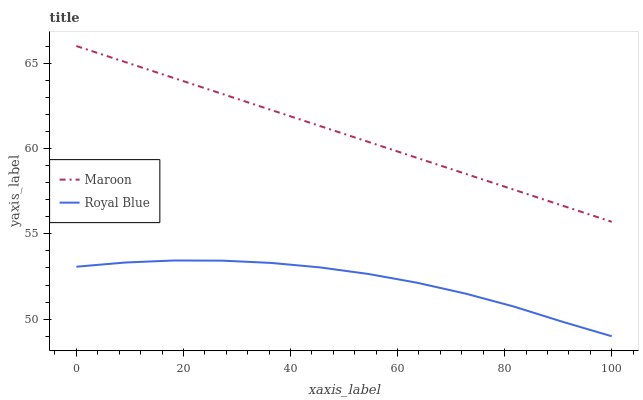Does Royal Blue have the minimum area under the curve?
Answer yes or no. Yes. Does Maroon have the maximum area under the curve?
Answer yes or no. Yes. Does Maroon have the minimum area under the curve?
Answer yes or no. No. Is Maroon the smoothest?
Answer yes or no. Yes. Is Royal Blue the roughest?
Answer yes or no. Yes. Is Maroon the roughest?
Answer yes or no. No. Does Royal Blue have the lowest value?
Answer yes or no. Yes. Does Maroon have the lowest value?
Answer yes or no. No. Does Maroon have the highest value?
Answer yes or no. Yes. Is Royal Blue less than Maroon?
Answer yes or no. Yes. Is Maroon greater than Royal Blue?
Answer yes or no. Yes. Does Royal Blue intersect Maroon?
Answer yes or no. No. 